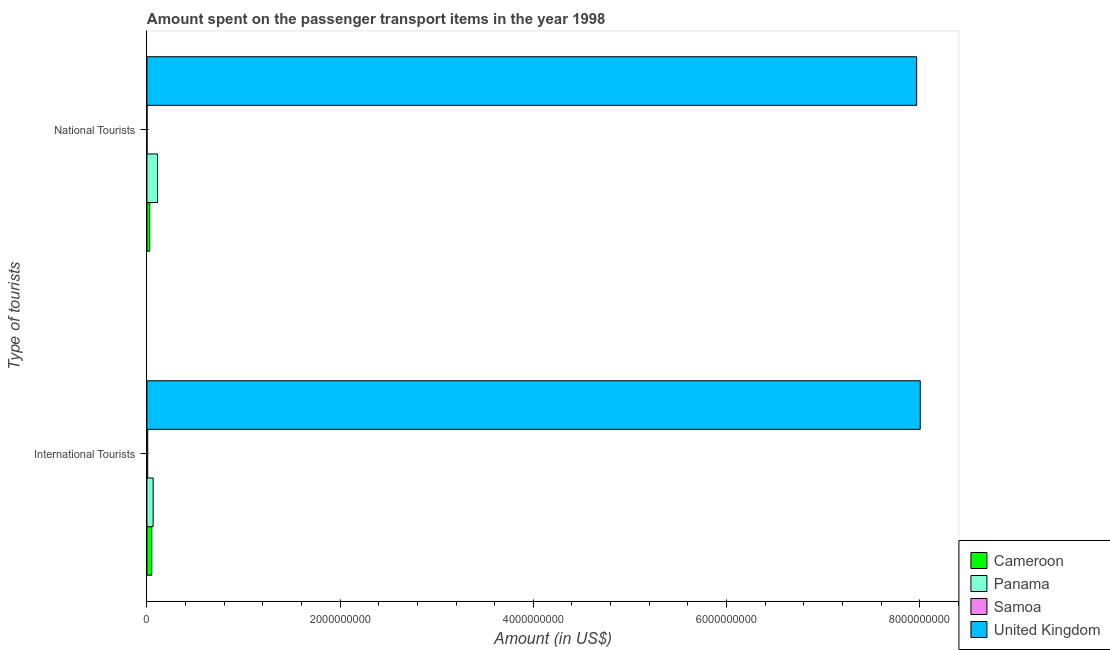How many different coloured bars are there?
Ensure brevity in your answer.  4. How many groups of bars are there?
Make the answer very short. 2. What is the label of the 1st group of bars from the top?
Keep it short and to the point. National Tourists. What is the amount spent on transport items of national tourists in Samoa?
Offer a very short reply. 6.00e+05. Across all countries, what is the maximum amount spent on transport items of international tourists?
Ensure brevity in your answer.  8.01e+09. Across all countries, what is the minimum amount spent on transport items of international tourists?
Make the answer very short. 8.00e+06. In which country was the amount spent on transport items of national tourists minimum?
Your answer should be very brief. Samoa. What is the total amount spent on transport items of international tourists in the graph?
Provide a succinct answer. 8.13e+09. What is the difference between the amount spent on transport items of national tourists in Panama and that in Cameroon?
Provide a succinct answer. 8.10e+07. What is the difference between the amount spent on transport items of national tourists in Samoa and the amount spent on transport items of international tourists in Cameroon?
Your response must be concise. -4.94e+07. What is the average amount spent on transport items of national tourists per country?
Give a very brief answer. 2.03e+09. What is the difference between the amount spent on transport items of national tourists and amount spent on transport items of international tourists in Cameroon?
Give a very brief answer. -2.10e+07. What is the ratio of the amount spent on transport items of international tourists in Cameroon to that in Panama?
Your answer should be very brief. 0.78. Is the amount spent on transport items of international tourists in Cameroon less than that in Samoa?
Your answer should be compact. No. What does the 1st bar from the top in National Tourists represents?
Your answer should be very brief. United Kingdom. Are the values on the major ticks of X-axis written in scientific E-notation?
Keep it short and to the point. No. Where does the legend appear in the graph?
Offer a terse response. Bottom right. How are the legend labels stacked?
Provide a succinct answer. Vertical. What is the title of the graph?
Keep it short and to the point. Amount spent on the passenger transport items in the year 1998. Does "Ukraine" appear as one of the legend labels in the graph?
Give a very brief answer. No. What is the label or title of the Y-axis?
Offer a very short reply. Type of tourists. What is the Amount (in US$) of Cameroon in International Tourists?
Your answer should be compact. 5.00e+07. What is the Amount (in US$) in Panama in International Tourists?
Offer a very short reply. 6.40e+07. What is the Amount (in US$) of Samoa in International Tourists?
Keep it short and to the point. 8.00e+06. What is the Amount (in US$) of United Kingdom in International Tourists?
Provide a succinct answer. 8.01e+09. What is the Amount (in US$) of Cameroon in National Tourists?
Ensure brevity in your answer.  2.90e+07. What is the Amount (in US$) in Panama in National Tourists?
Your response must be concise. 1.10e+08. What is the Amount (in US$) of Samoa in National Tourists?
Make the answer very short. 6.00e+05. What is the Amount (in US$) of United Kingdom in National Tourists?
Give a very brief answer. 7.97e+09. Across all Type of tourists, what is the maximum Amount (in US$) of Panama?
Offer a very short reply. 1.10e+08. Across all Type of tourists, what is the maximum Amount (in US$) in Samoa?
Provide a succinct answer. 8.00e+06. Across all Type of tourists, what is the maximum Amount (in US$) in United Kingdom?
Your answer should be compact. 8.01e+09. Across all Type of tourists, what is the minimum Amount (in US$) of Cameroon?
Your answer should be very brief. 2.90e+07. Across all Type of tourists, what is the minimum Amount (in US$) in Panama?
Offer a terse response. 6.40e+07. Across all Type of tourists, what is the minimum Amount (in US$) of Samoa?
Your response must be concise. 6.00e+05. Across all Type of tourists, what is the minimum Amount (in US$) of United Kingdom?
Provide a succinct answer. 7.97e+09. What is the total Amount (in US$) of Cameroon in the graph?
Provide a succinct answer. 7.90e+07. What is the total Amount (in US$) in Panama in the graph?
Give a very brief answer. 1.74e+08. What is the total Amount (in US$) in Samoa in the graph?
Offer a very short reply. 8.60e+06. What is the total Amount (in US$) in United Kingdom in the graph?
Your answer should be very brief. 1.60e+1. What is the difference between the Amount (in US$) of Cameroon in International Tourists and that in National Tourists?
Offer a terse response. 2.10e+07. What is the difference between the Amount (in US$) in Panama in International Tourists and that in National Tourists?
Provide a succinct answer. -4.60e+07. What is the difference between the Amount (in US$) in Samoa in International Tourists and that in National Tourists?
Offer a very short reply. 7.40e+06. What is the difference between the Amount (in US$) of United Kingdom in International Tourists and that in National Tourists?
Ensure brevity in your answer.  3.70e+07. What is the difference between the Amount (in US$) in Cameroon in International Tourists and the Amount (in US$) in Panama in National Tourists?
Your answer should be very brief. -6.00e+07. What is the difference between the Amount (in US$) in Cameroon in International Tourists and the Amount (in US$) in Samoa in National Tourists?
Your answer should be very brief. 4.94e+07. What is the difference between the Amount (in US$) in Cameroon in International Tourists and the Amount (in US$) in United Kingdom in National Tourists?
Offer a terse response. -7.92e+09. What is the difference between the Amount (in US$) in Panama in International Tourists and the Amount (in US$) in Samoa in National Tourists?
Make the answer very short. 6.34e+07. What is the difference between the Amount (in US$) of Panama in International Tourists and the Amount (in US$) of United Kingdom in National Tourists?
Offer a terse response. -7.90e+09. What is the difference between the Amount (in US$) in Samoa in International Tourists and the Amount (in US$) in United Kingdom in National Tourists?
Offer a very short reply. -7.96e+09. What is the average Amount (in US$) of Cameroon per Type of tourists?
Keep it short and to the point. 3.95e+07. What is the average Amount (in US$) in Panama per Type of tourists?
Make the answer very short. 8.70e+07. What is the average Amount (in US$) of Samoa per Type of tourists?
Provide a short and direct response. 4.30e+06. What is the average Amount (in US$) in United Kingdom per Type of tourists?
Provide a short and direct response. 7.99e+09. What is the difference between the Amount (in US$) in Cameroon and Amount (in US$) in Panama in International Tourists?
Provide a short and direct response. -1.40e+07. What is the difference between the Amount (in US$) of Cameroon and Amount (in US$) of Samoa in International Tourists?
Ensure brevity in your answer.  4.20e+07. What is the difference between the Amount (in US$) of Cameroon and Amount (in US$) of United Kingdom in International Tourists?
Your answer should be very brief. -7.96e+09. What is the difference between the Amount (in US$) of Panama and Amount (in US$) of Samoa in International Tourists?
Provide a succinct answer. 5.60e+07. What is the difference between the Amount (in US$) of Panama and Amount (in US$) of United Kingdom in International Tourists?
Offer a terse response. -7.94e+09. What is the difference between the Amount (in US$) of Samoa and Amount (in US$) of United Kingdom in International Tourists?
Your answer should be compact. -8.00e+09. What is the difference between the Amount (in US$) of Cameroon and Amount (in US$) of Panama in National Tourists?
Your answer should be compact. -8.10e+07. What is the difference between the Amount (in US$) in Cameroon and Amount (in US$) in Samoa in National Tourists?
Ensure brevity in your answer.  2.84e+07. What is the difference between the Amount (in US$) of Cameroon and Amount (in US$) of United Kingdom in National Tourists?
Your answer should be compact. -7.94e+09. What is the difference between the Amount (in US$) of Panama and Amount (in US$) of Samoa in National Tourists?
Make the answer very short. 1.09e+08. What is the difference between the Amount (in US$) of Panama and Amount (in US$) of United Kingdom in National Tourists?
Offer a very short reply. -7.86e+09. What is the difference between the Amount (in US$) in Samoa and Amount (in US$) in United Kingdom in National Tourists?
Give a very brief answer. -7.97e+09. What is the ratio of the Amount (in US$) in Cameroon in International Tourists to that in National Tourists?
Your response must be concise. 1.72. What is the ratio of the Amount (in US$) in Panama in International Tourists to that in National Tourists?
Offer a terse response. 0.58. What is the ratio of the Amount (in US$) of Samoa in International Tourists to that in National Tourists?
Keep it short and to the point. 13.32. What is the difference between the highest and the second highest Amount (in US$) in Cameroon?
Your answer should be very brief. 2.10e+07. What is the difference between the highest and the second highest Amount (in US$) of Panama?
Your answer should be very brief. 4.60e+07. What is the difference between the highest and the second highest Amount (in US$) of Samoa?
Give a very brief answer. 7.40e+06. What is the difference between the highest and the second highest Amount (in US$) of United Kingdom?
Provide a succinct answer. 3.70e+07. What is the difference between the highest and the lowest Amount (in US$) of Cameroon?
Keep it short and to the point. 2.10e+07. What is the difference between the highest and the lowest Amount (in US$) in Panama?
Your answer should be very brief. 4.60e+07. What is the difference between the highest and the lowest Amount (in US$) in Samoa?
Ensure brevity in your answer.  7.40e+06. What is the difference between the highest and the lowest Amount (in US$) in United Kingdom?
Your answer should be compact. 3.70e+07. 